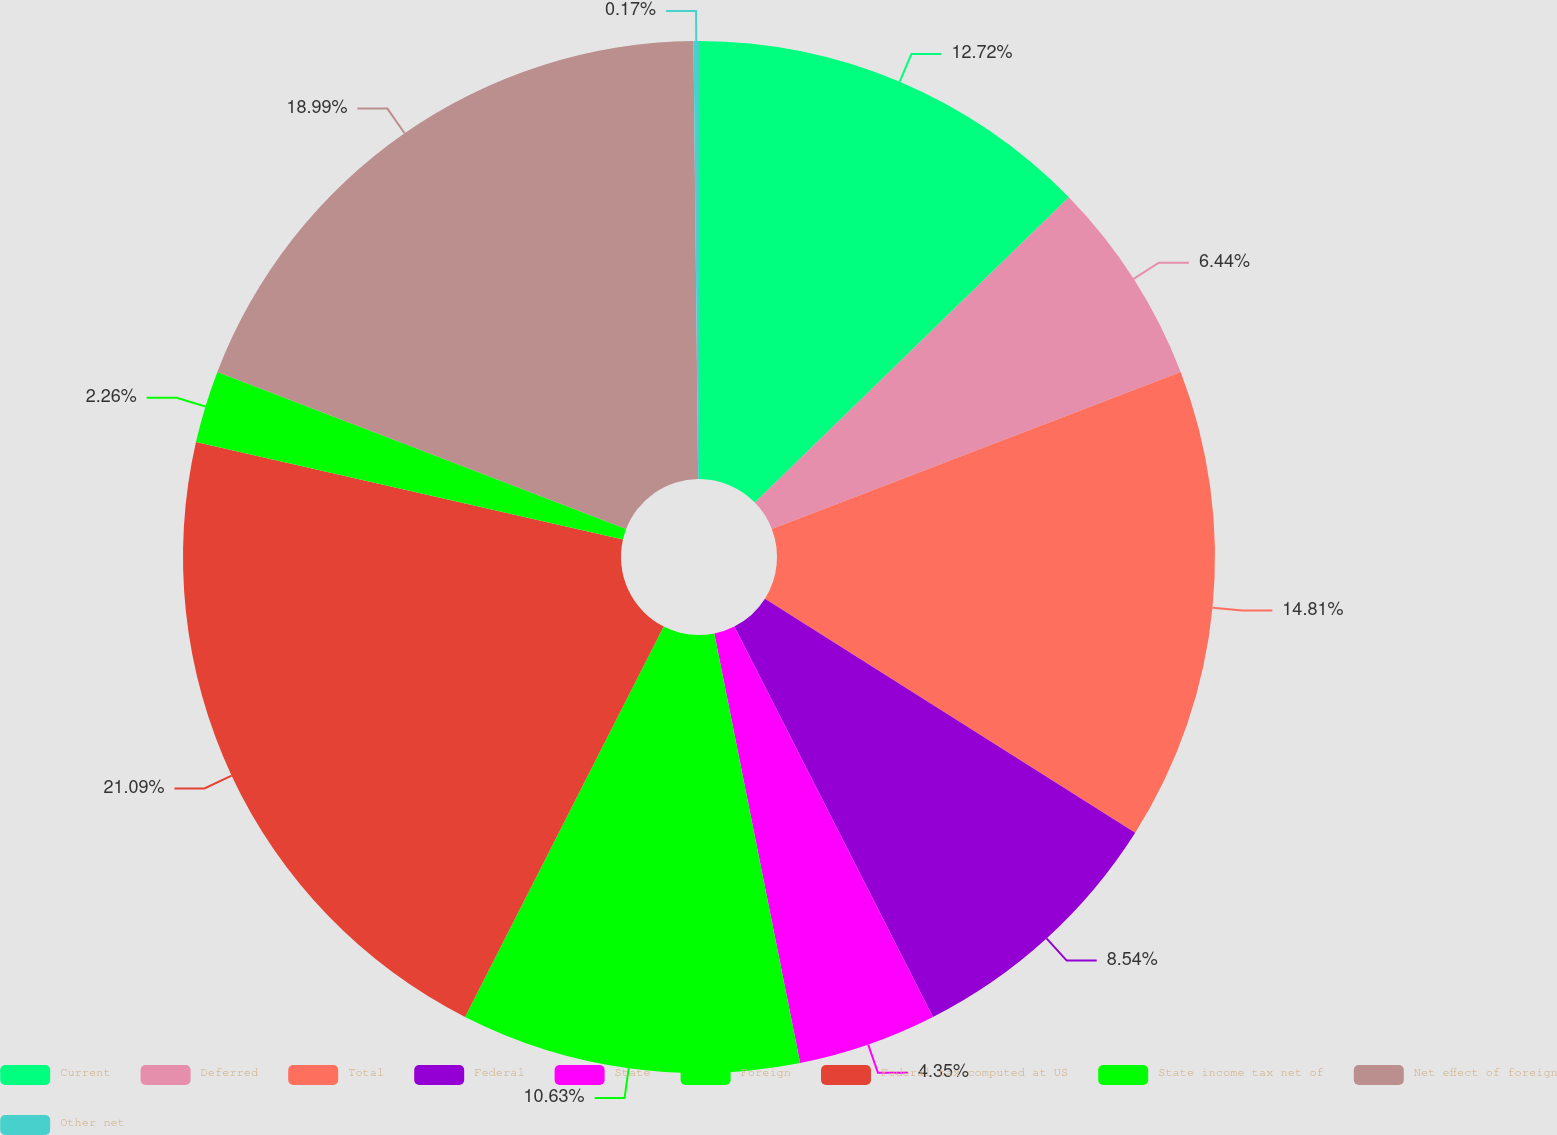Convert chart. <chart><loc_0><loc_0><loc_500><loc_500><pie_chart><fcel>Current<fcel>Deferred<fcel>Total<fcel>Federal<fcel>State<fcel>Foreign<fcel>Federal tax computed at US<fcel>State income tax net of<fcel>Net effect of foreign<fcel>Other net<nl><fcel>12.72%<fcel>6.44%<fcel>14.81%<fcel>8.54%<fcel>4.35%<fcel>10.63%<fcel>21.09%<fcel>2.26%<fcel>18.99%<fcel>0.17%<nl></chart> 